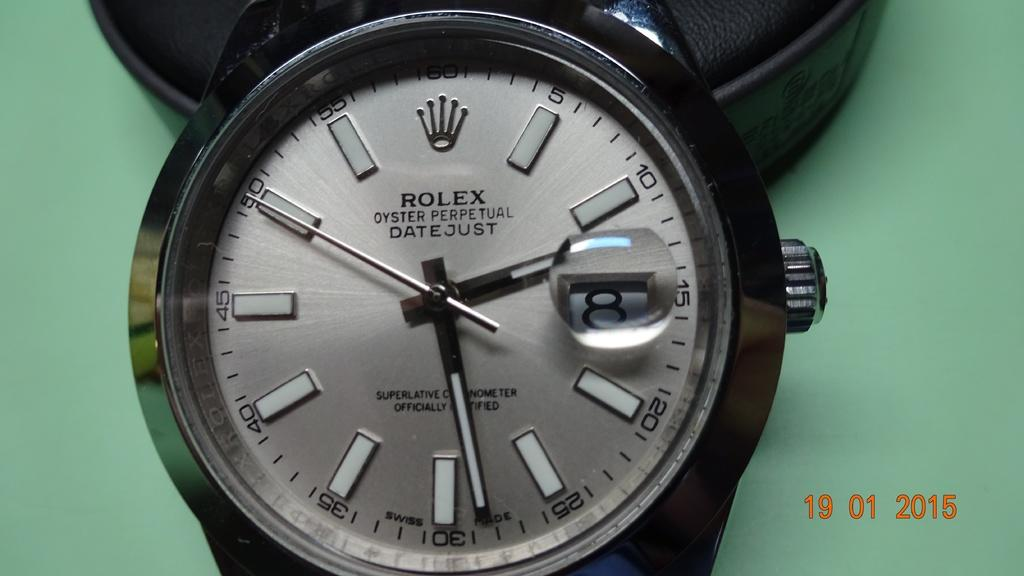<image>
Create a compact narrative representing the image presented. A Rolex watch says that it has oyster perpetual datejust. 